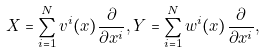<formula> <loc_0><loc_0><loc_500><loc_500>X = \sum _ { i = 1 } ^ { N } v ^ { i } ( { x } ) \frac { \partial } { \partial x ^ { i } } , Y = \sum _ { i = 1 } ^ { N } w ^ { i } ( { x } ) \frac { \partial } { \partial x ^ { i } } ,</formula> 